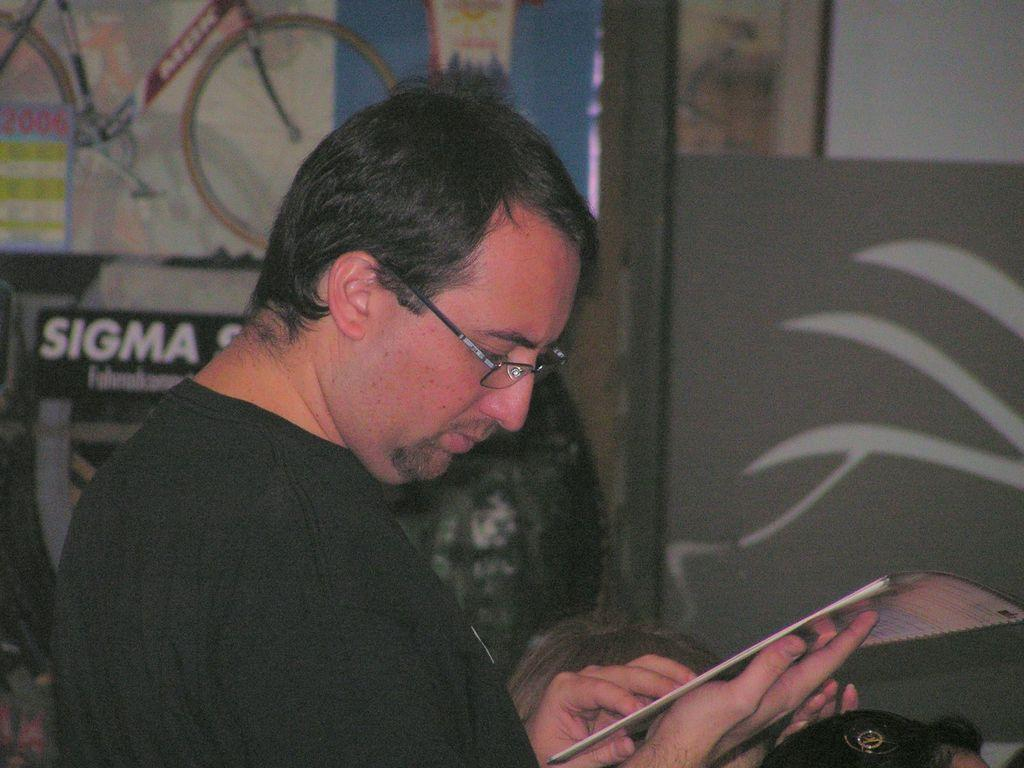What is the man in the image doing? The man is standing in the image. What is the man holding in his hands? The man is holding a book in his hands. What is the man wearing on his upper body? The man is wearing a black T-shirt. What accessory is the man wearing on his face? The man is wearing spectacles. What can be seen attached to the wall in the background of the image? There are posts attached to the wall in the background of the image. How many clocks are hanging on the man's elbow in the image? There are no clocks visible on the man's elbow in the image. What type of connection is the man making with the book in the image? The question is unclear and does not relate to any details in the image. The man is simply holding a book in his hands, not making any specific connection with it. 